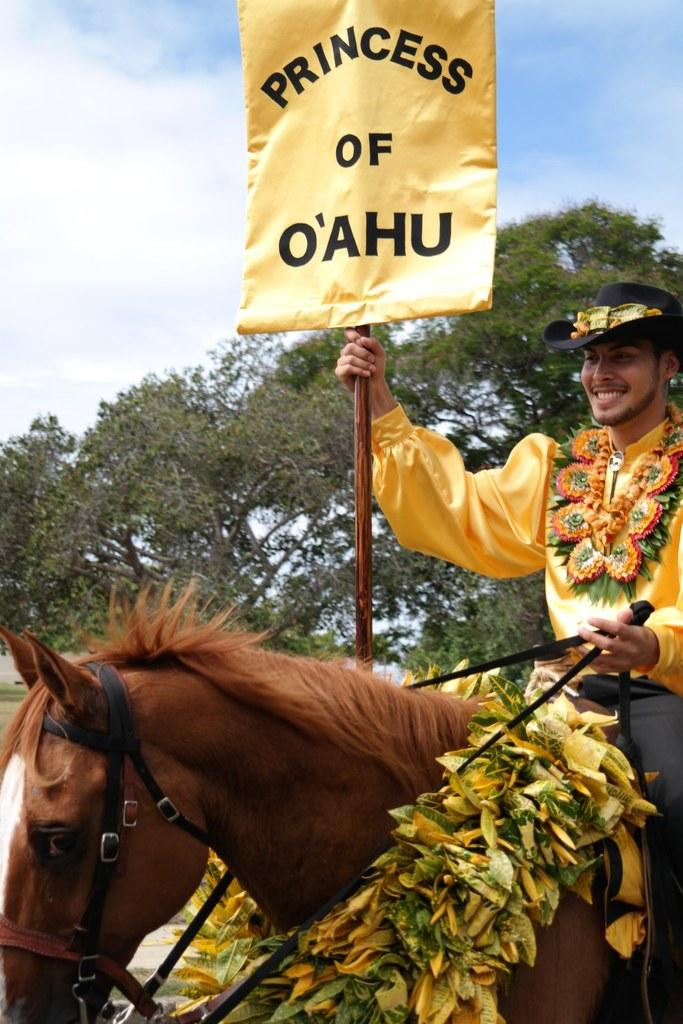What is the main subject of the image? There is a person in the image. What is the person wearing? The person is wearing a yellow dress. What is the person doing in the image? The person is riding a horse. Can you describe the horse in the image? The horse has a garland on it. What is the person holding in the image? The person is holding a banner. What can be seen in the background of the image? There is a tree and the sky visible in the background of the image. What is the condition of the sky in the image? Clouds are present in the sky. What type of knife can be seen in the image? There is no knife present in the image. Is the person in jail in the image? There is no indication of a jail or any person being in jail in the image. 